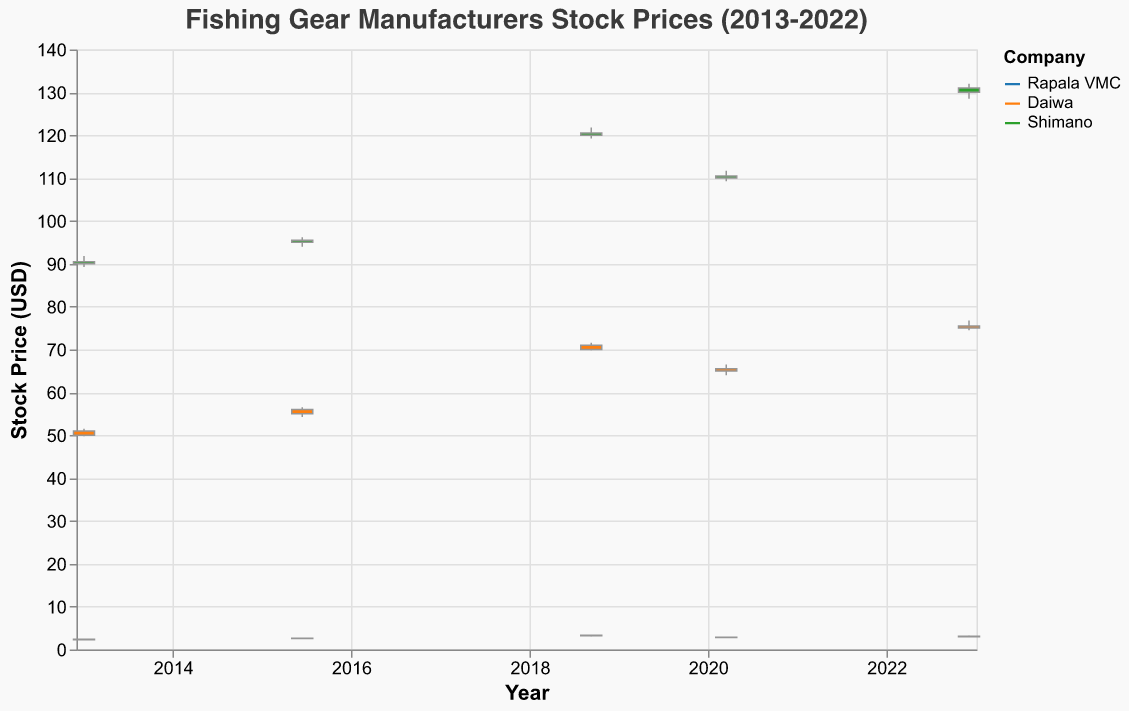What's the highest stock price achieved by Shimano during the given periods? To find the highest stock price of Shimano, we look across all dates and identify the maximum value in the "High" column for Shimano. The highest price is 132.00 on 2022-12-05.
Answer: 132.00 Which company experienced the highest stock price on 2018-09-10? On 2018-09-10, we compare the "High" prices of the three companies. Shimano had the highest price of 121.80.
Answer: Shimano What was the trend in closing prices for Daiwa from 2013 to 2022? Track Daiwa's closing prices over the years: 51.00 (2013), 56.00 (2015), 71.00 (2018), 65.50 (2020), 75.50 (2022). The trend shows a general increase with a dip in 2020.
Answer: Mostly increasing, with a dip in 2020 How did Rapala VMC's 2013 stock price compare to its 2022 stock price? Compare the closing prices: 2.40 (2013) vs 3.10 (2022). The 2022 stock price is higher than the 2013 stock price.
Answer: Higher in 2022 During which year did Shimano stock see the lowest closing price? To find the year with the lowest closing price for Shimano, check the "Close" values: 90.50 (2013), 95.50 (2015), 120.50 (2018), 110.50 (2020), 131.00 (2022). The lowest closing price was in 2013.
Answer: 2013 Did Daiwa's stock price ever fall below 55.00 in the given periods? Examine the "Low" prices for Daiwa: 49.75 (2013), 54.25 (2015), 69.85 (2018), 64.00 (2020), 74.50 (2022). The price fell below 55.00 in 2013 and 2015.
Answer: Yes, in 2013 and 2015 What's the average closing price of Rapala VMC across all the given periods? Calculate the average of Rapala VMC's closing prices: (2.40 + 2.60 + 3.30 + 2.85 + 3.10) / 5 = (14.25/5) = 2.85
Answer: 2.85 Which company had the most stable stock prices over the period? Determine stability by checking the range (High - Low) for each company's stock prices across the dates. Rapala VMC ranges: [0.25, 0.22, 0.30, 0.20, 0.30], Daiwa ranges: [1.75, 2.25, 1.70, 2.50, 2.25], Shimano ranges: [2.55, 2.20, 2.55, 2.45, 3.50]. Rapala VMC had the smallest ranges, indicating more stability.
Answer: Rapala VMC What is the volume trend for Daiwa from 2013 to 2022? Check Daiwa's volume over the years: 200000 (2013), 220000 (2015), 240000 (2018), 210000 (2020), 230000 (2022). The volume fluctuates but mostly increases over the years.
Answer: Mostly increasing 